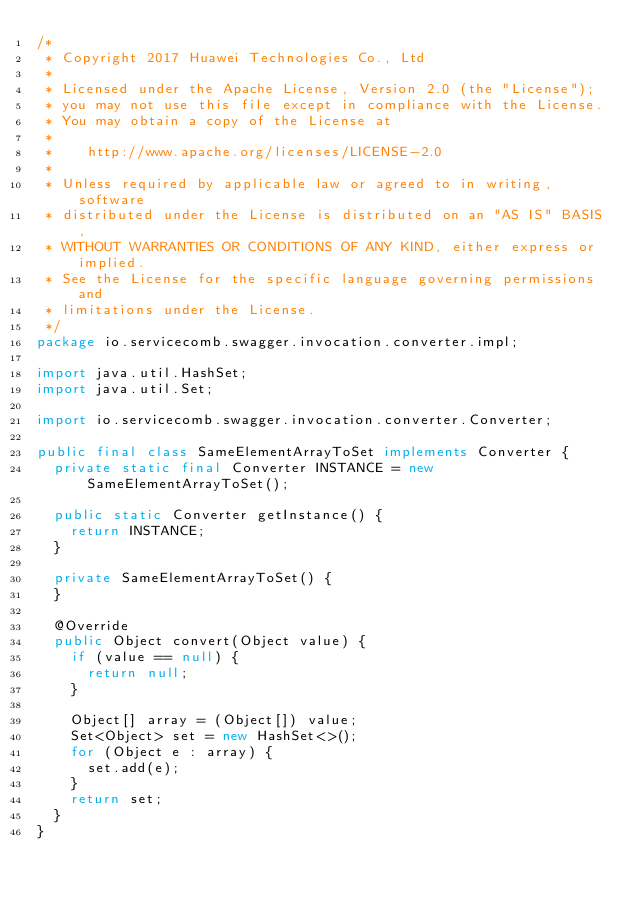<code> <loc_0><loc_0><loc_500><loc_500><_Java_>/*
 * Copyright 2017 Huawei Technologies Co., Ltd
 *
 * Licensed under the Apache License, Version 2.0 (the "License");
 * you may not use this file except in compliance with the License.
 * You may obtain a copy of the License at
 *
 *    http://www.apache.org/licenses/LICENSE-2.0
 *
 * Unless required by applicable law or agreed to in writing, software
 * distributed under the License is distributed on an "AS IS" BASIS,
 * WITHOUT WARRANTIES OR CONDITIONS OF ANY KIND, either express or implied.
 * See the License for the specific language governing permissions and
 * limitations under the License.
 */
package io.servicecomb.swagger.invocation.converter.impl;

import java.util.HashSet;
import java.util.Set;

import io.servicecomb.swagger.invocation.converter.Converter;

public final class SameElementArrayToSet implements Converter {
  private static final Converter INSTANCE = new SameElementArrayToSet();

  public static Converter getInstance() {
    return INSTANCE;
  }

  private SameElementArrayToSet() {
  }

  @Override
  public Object convert(Object value) {
    if (value == null) {
      return null;
    }

    Object[] array = (Object[]) value;
    Set<Object> set = new HashSet<>();
    for (Object e : array) {
      set.add(e);
    }
    return set;
  }
}
</code> 